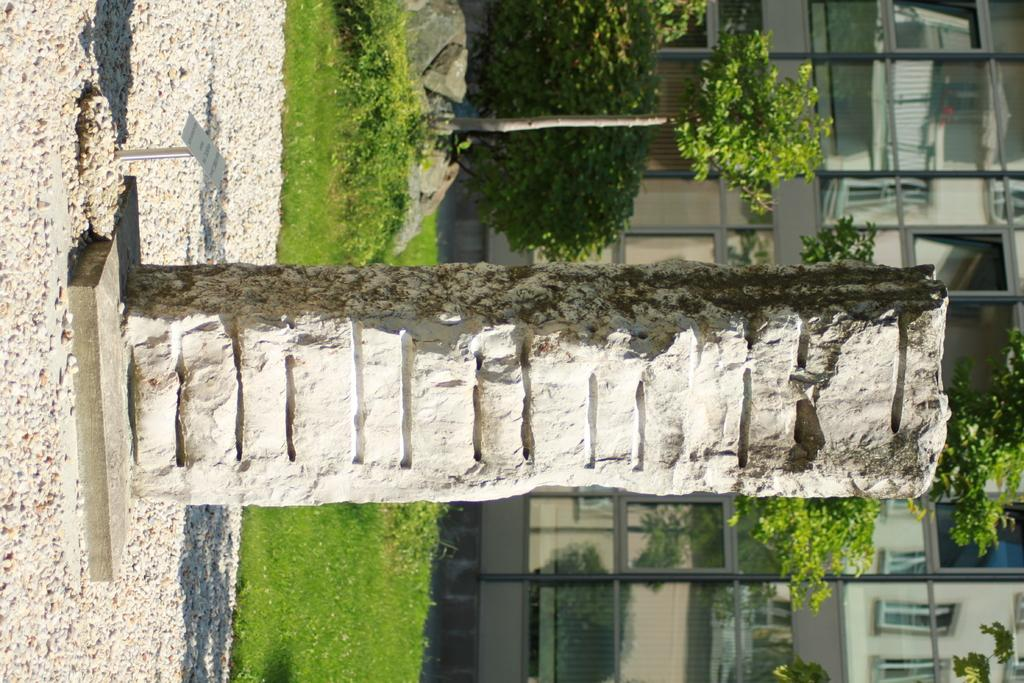What is the main subject on the platform in the image? There is a sculpture on a platform in the image. What can be found near the sculpture? There is a name board in the image. What type of natural elements are present in the image? There are stones, grass, and trees in the image. What is visible in the background of the image? There is a building with windows in the background of the image. What type of hook can be seen on the wrist of the sculpture in the image? There is no hook visible on the wrist of the sculpture in the image. Is there a party happening in the image? There is no indication of a party in the image. 